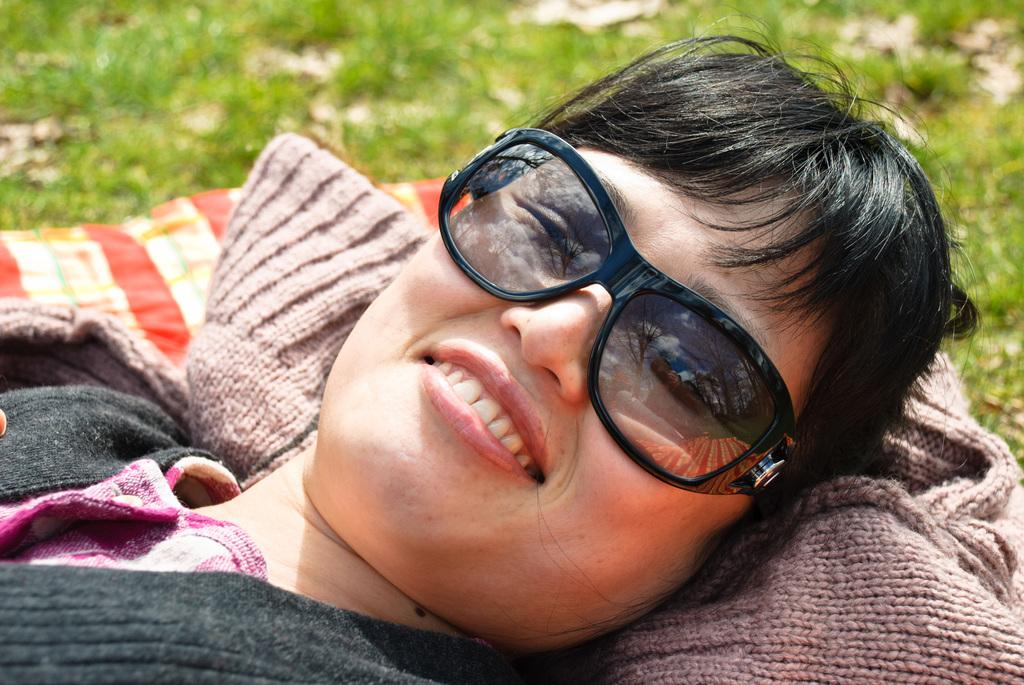What is the main subject of the image? The main subject of the image is a woman. What is the woman doing in the image? The woman is lying down. What is the woman's facial expression in the image? The woman is smiling. What type of surface is visible in the image? There is grass visible in the image. What else can be seen in the image besides the woman? There are clothes visible in the image. What type of relation does the woman have with the robin in the image? There is no robin present in the image, so the woman does not have any relation with a robin in the image. What thought is the woman having in the image? The image does not provide any information about the woman's thoughts, so it cannot be determined from the picture. 